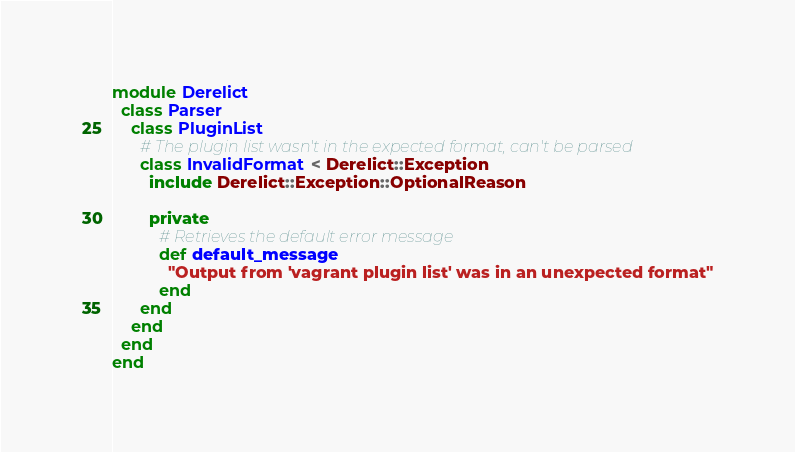<code> <loc_0><loc_0><loc_500><loc_500><_Ruby_>module Derelict
  class Parser
    class PluginList
      # The plugin list wasn't in the expected format, can't be parsed
      class InvalidFormat < Derelict::Exception
        include Derelict::Exception::OptionalReason

        private
          # Retrieves the default error message
          def default_message
            "Output from 'vagrant plugin list' was in an unexpected format"
          end
      end
    end
  end
end
</code> 